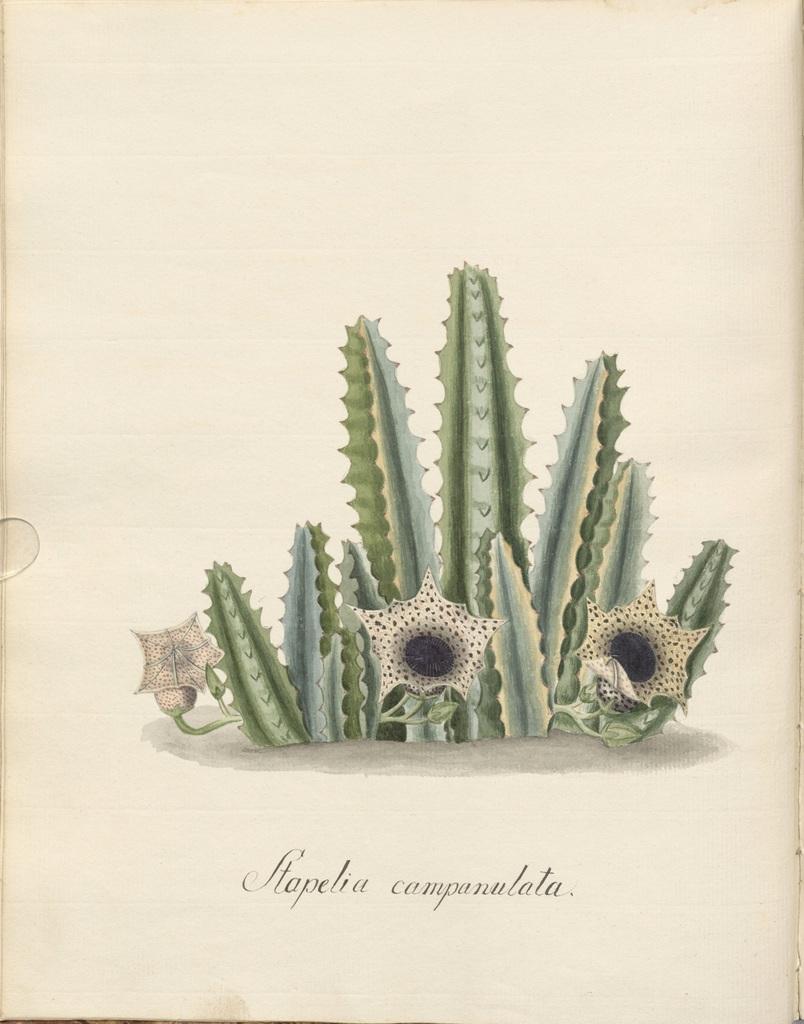How would you summarize this image in a sentence or two? In this image there is a paper. In the center of the paper we can see the cactus plant and there are flowers. At the bottom there is text. 